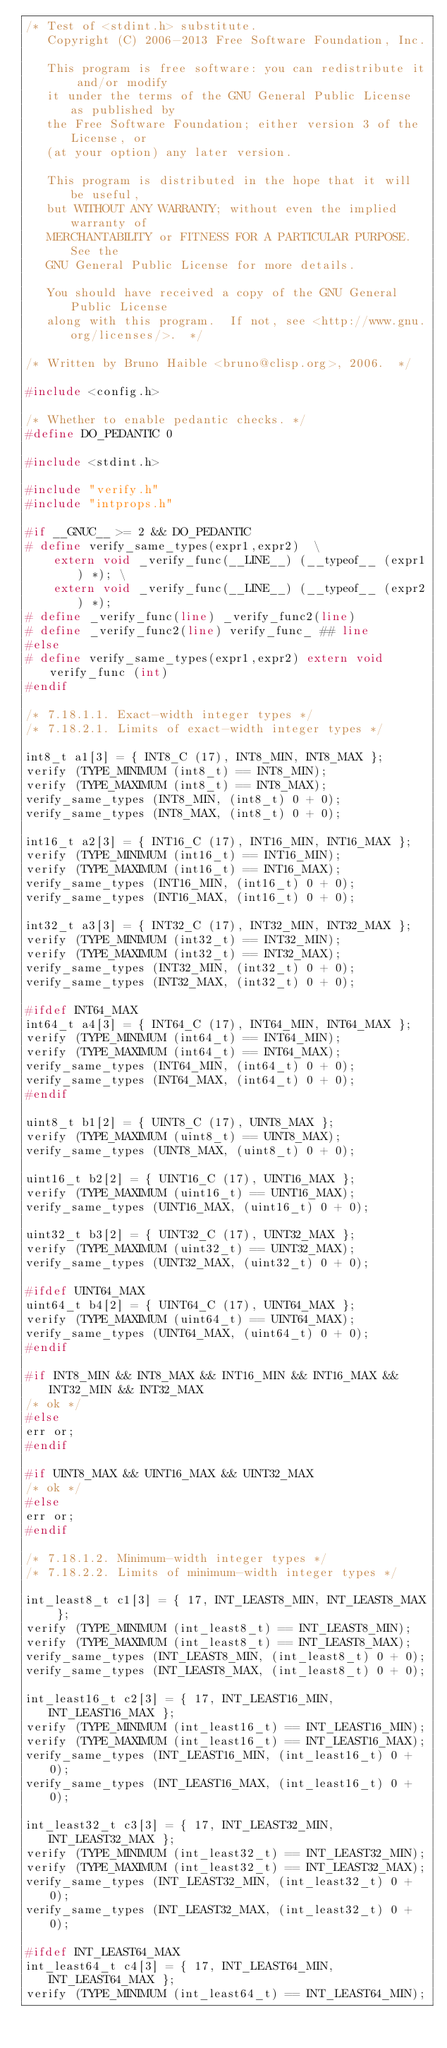Convert code to text. <code><loc_0><loc_0><loc_500><loc_500><_C_>/* Test of <stdint.h> substitute.
   Copyright (C) 2006-2013 Free Software Foundation, Inc.

   This program is free software: you can redistribute it and/or modify
   it under the terms of the GNU General Public License as published by
   the Free Software Foundation; either version 3 of the License, or
   (at your option) any later version.

   This program is distributed in the hope that it will be useful,
   but WITHOUT ANY WARRANTY; without even the implied warranty of
   MERCHANTABILITY or FITNESS FOR A PARTICULAR PURPOSE.  See the
   GNU General Public License for more details.

   You should have received a copy of the GNU General Public License
   along with this program.  If not, see <http://www.gnu.org/licenses/>.  */

/* Written by Bruno Haible <bruno@clisp.org>, 2006.  */

#include <config.h>

/* Whether to enable pedantic checks. */
#define DO_PEDANTIC 0

#include <stdint.h>

#include "verify.h"
#include "intprops.h"

#if __GNUC__ >= 2 && DO_PEDANTIC
# define verify_same_types(expr1,expr2)  \
    extern void _verify_func(__LINE__) (__typeof__ (expr1) *); \
    extern void _verify_func(__LINE__) (__typeof__ (expr2) *);
# define _verify_func(line) _verify_func2(line)
# define _verify_func2(line) verify_func_ ## line
#else
# define verify_same_types(expr1,expr2) extern void verify_func (int)
#endif

/* 7.18.1.1. Exact-width integer types */
/* 7.18.2.1. Limits of exact-width integer types */

int8_t a1[3] = { INT8_C (17), INT8_MIN, INT8_MAX };
verify (TYPE_MINIMUM (int8_t) == INT8_MIN);
verify (TYPE_MAXIMUM (int8_t) == INT8_MAX);
verify_same_types (INT8_MIN, (int8_t) 0 + 0);
verify_same_types (INT8_MAX, (int8_t) 0 + 0);

int16_t a2[3] = { INT16_C (17), INT16_MIN, INT16_MAX };
verify (TYPE_MINIMUM (int16_t) == INT16_MIN);
verify (TYPE_MAXIMUM (int16_t) == INT16_MAX);
verify_same_types (INT16_MIN, (int16_t) 0 + 0);
verify_same_types (INT16_MAX, (int16_t) 0 + 0);

int32_t a3[3] = { INT32_C (17), INT32_MIN, INT32_MAX };
verify (TYPE_MINIMUM (int32_t) == INT32_MIN);
verify (TYPE_MAXIMUM (int32_t) == INT32_MAX);
verify_same_types (INT32_MIN, (int32_t) 0 + 0);
verify_same_types (INT32_MAX, (int32_t) 0 + 0);

#ifdef INT64_MAX
int64_t a4[3] = { INT64_C (17), INT64_MIN, INT64_MAX };
verify (TYPE_MINIMUM (int64_t) == INT64_MIN);
verify (TYPE_MAXIMUM (int64_t) == INT64_MAX);
verify_same_types (INT64_MIN, (int64_t) 0 + 0);
verify_same_types (INT64_MAX, (int64_t) 0 + 0);
#endif

uint8_t b1[2] = { UINT8_C (17), UINT8_MAX };
verify (TYPE_MAXIMUM (uint8_t) == UINT8_MAX);
verify_same_types (UINT8_MAX, (uint8_t) 0 + 0);

uint16_t b2[2] = { UINT16_C (17), UINT16_MAX };
verify (TYPE_MAXIMUM (uint16_t) == UINT16_MAX);
verify_same_types (UINT16_MAX, (uint16_t) 0 + 0);

uint32_t b3[2] = { UINT32_C (17), UINT32_MAX };
verify (TYPE_MAXIMUM (uint32_t) == UINT32_MAX);
verify_same_types (UINT32_MAX, (uint32_t) 0 + 0);

#ifdef UINT64_MAX
uint64_t b4[2] = { UINT64_C (17), UINT64_MAX };
verify (TYPE_MAXIMUM (uint64_t) == UINT64_MAX);
verify_same_types (UINT64_MAX, (uint64_t) 0 + 0);
#endif

#if INT8_MIN && INT8_MAX && INT16_MIN && INT16_MAX && INT32_MIN && INT32_MAX
/* ok */
#else
err or;
#endif

#if UINT8_MAX && UINT16_MAX && UINT32_MAX
/* ok */
#else
err or;
#endif

/* 7.18.1.2. Minimum-width integer types */
/* 7.18.2.2. Limits of minimum-width integer types */

int_least8_t c1[3] = { 17, INT_LEAST8_MIN, INT_LEAST8_MAX };
verify (TYPE_MINIMUM (int_least8_t) == INT_LEAST8_MIN);
verify (TYPE_MAXIMUM (int_least8_t) == INT_LEAST8_MAX);
verify_same_types (INT_LEAST8_MIN, (int_least8_t) 0 + 0);
verify_same_types (INT_LEAST8_MAX, (int_least8_t) 0 + 0);

int_least16_t c2[3] = { 17, INT_LEAST16_MIN, INT_LEAST16_MAX };
verify (TYPE_MINIMUM (int_least16_t) == INT_LEAST16_MIN);
verify (TYPE_MAXIMUM (int_least16_t) == INT_LEAST16_MAX);
verify_same_types (INT_LEAST16_MIN, (int_least16_t) 0 + 0);
verify_same_types (INT_LEAST16_MAX, (int_least16_t) 0 + 0);

int_least32_t c3[3] = { 17, INT_LEAST32_MIN, INT_LEAST32_MAX };
verify (TYPE_MINIMUM (int_least32_t) == INT_LEAST32_MIN);
verify (TYPE_MAXIMUM (int_least32_t) == INT_LEAST32_MAX);
verify_same_types (INT_LEAST32_MIN, (int_least32_t) 0 + 0);
verify_same_types (INT_LEAST32_MAX, (int_least32_t) 0 + 0);

#ifdef INT_LEAST64_MAX
int_least64_t c4[3] = { 17, INT_LEAST64_MIN, INT_LEAST64_MAX };
verify (TYPE_MINIMUM (int_least64_t) == INT_LEAST64_MIN);</code> 